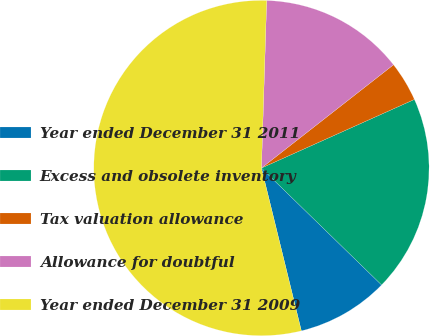Convert chart. <chart><loc_0><loc_0><loc_500><loc_500><pie_chart><fcel>Year ended December 31 2011<fcel>Excess and obsolete inventory<fcel>Tax valuation allowance<fcel>Allowance for doubtful<fcel>Year ended December 31 2009<nl><fcel>8.89%<fcel>18.99%<fcel>3.85%<fcel>13.94%<fcel>54.32%<nl></chart> 